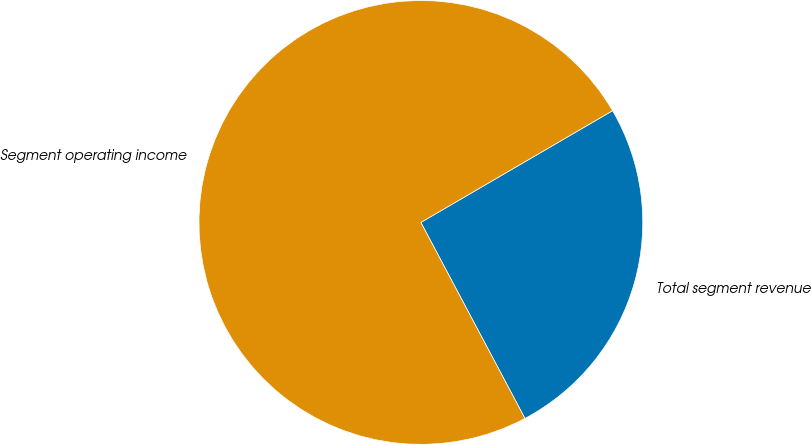<chart> <loc_0><loc_0><loc_500><loc_500><pie_chart><fcel>Total segment revenue<fcel>Segment operating income<nl><fcel>25.63%<fcel>74.37%<nl></chart> 